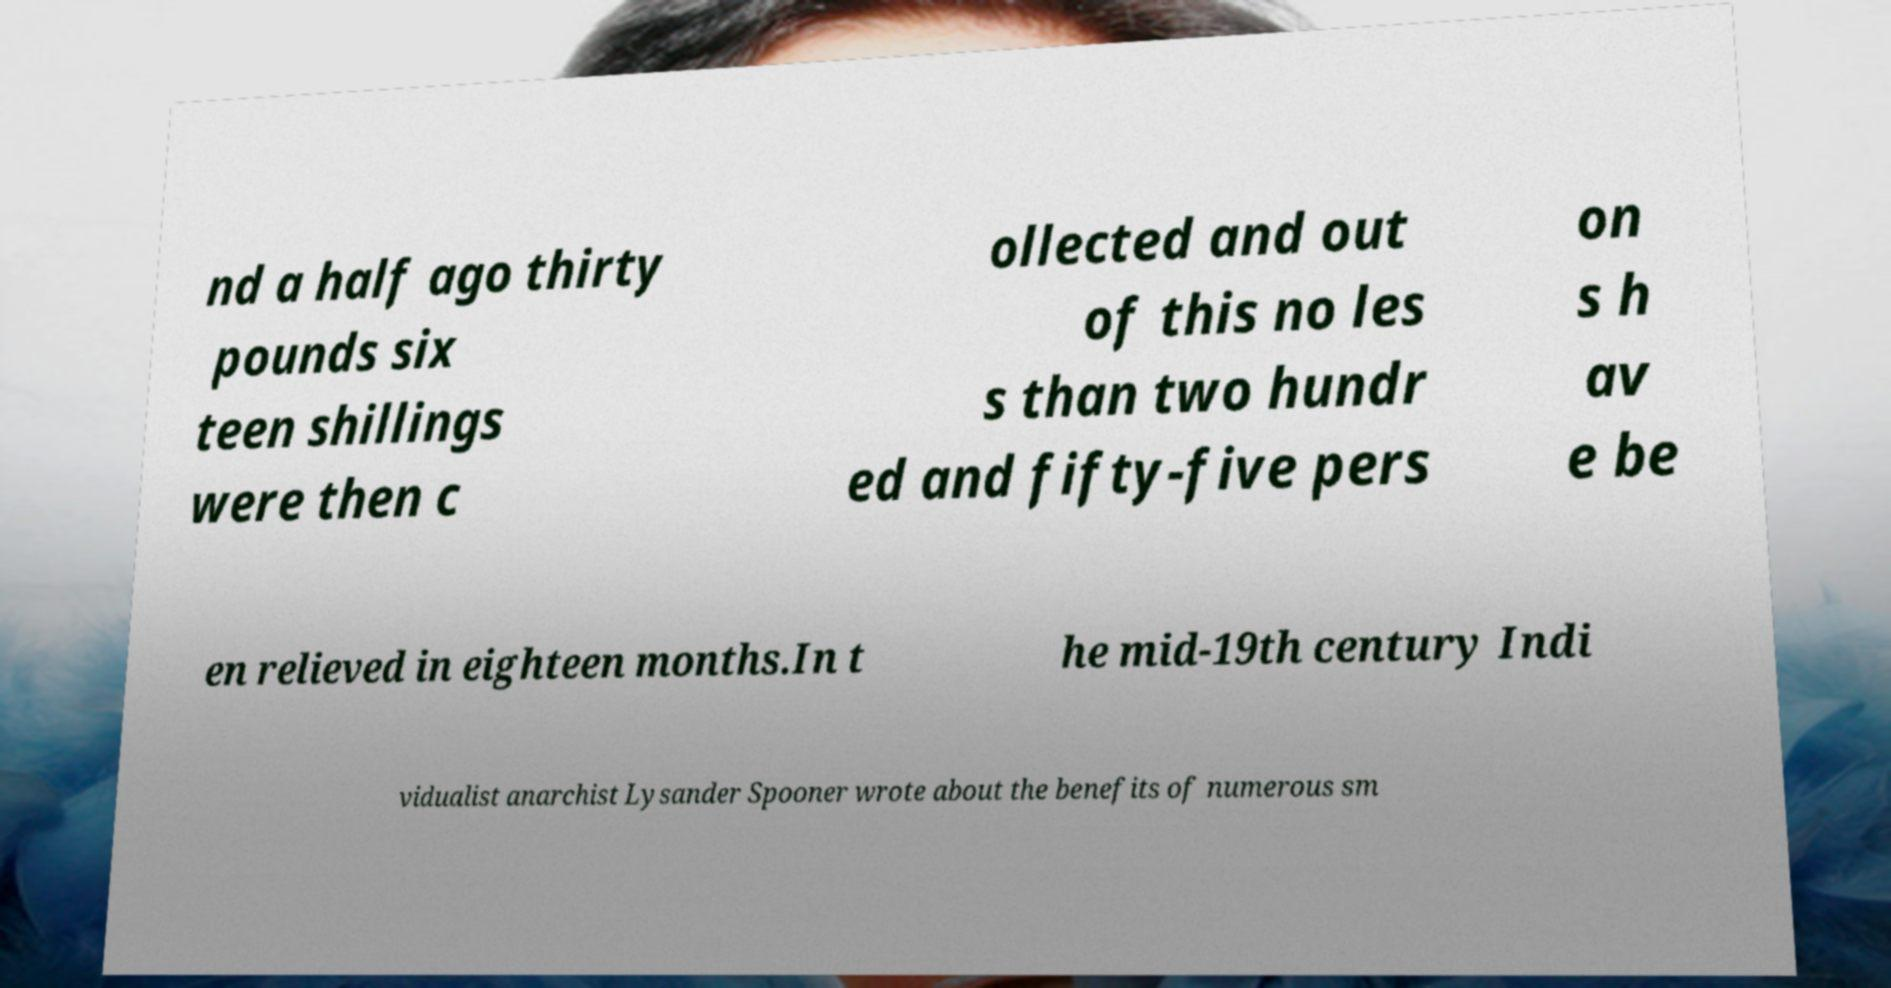For documentation purposes, I need the text within this image transcribed. Could you provide that? nd a half ago thirty pounds six teen shillings were then c ollected and out of this no les s than two hundr ed and fifty-five pers on s h av e be en relieved in eighteen months.In t he mid-19th century Indi vidualist anarchist Lysander Spooner wrote about the benefits of numerous sm 